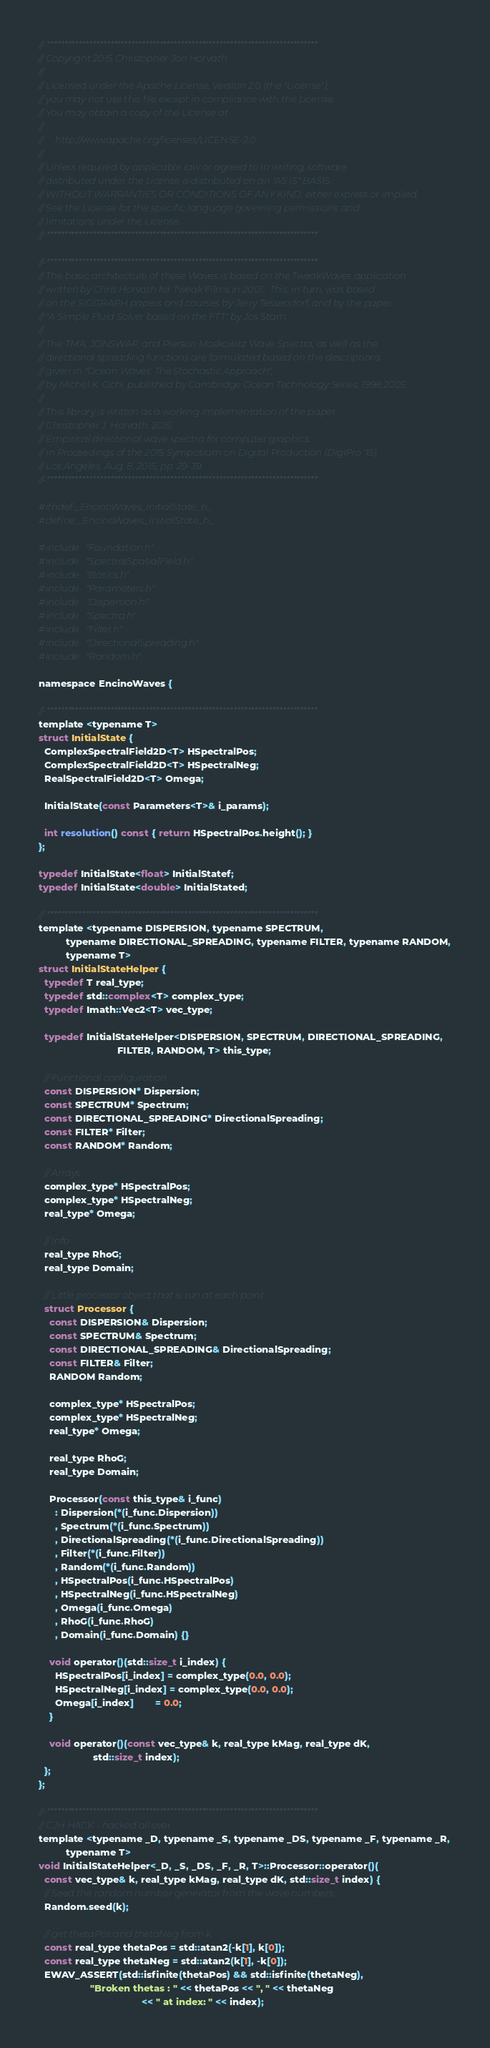<code> <loc_0><loc_0><loc_500><loc_500><_C_>//-*****************************************************************************
// Copyright 2015 Christopher Jon Horvath
//
// Licensed under the Apache License, Version 2.0 (the "License");
// you may not use this file except in compliance with the License.
// You may obtain a copy of the License at
//
//     http://www.apache.org/licenses/LICENSE-2.0
//
// Unless required by applicable law or agreed to in writing, software
// distributed under the License is distributed on an "AS IS" BASIS,
// WITHOUT WARRANTIES OR CONDITIONS OF ANY KIND, either express or implied.
// See the License for the specific language governing permissions and
// limitations under the License.
//-*****************************************************************************

//-*****************************************************************************
// The basic architecture of these Waves is based on the TweakWaves application
// written by Chris Horvath for Tweak Films in 2001.  This, in turn, was based
// on the SIGGRAPH papers and courses by Jerry Tessendorf, and by the paper
// "A Simple Fluid Solver based on the FTT" by Jos Stam.
//
// The TMA, JONSWAP, and Pierson Moskowitz Wave Spectra, as well as the
// directional spreading functions are formulated based on the descriptions
// given in "Ocean Waves: The Stochastic Approach",
// by Michel K. Ochi, published by Cambridge Ocean Technology Series, 1998,2005.
//
// This library is written as a working implementation of the paper:
// Christopher J. Horvath. 2015.
// Empirical directional wave spectra for computer graphics.
// In Proceedings of the 2015 Symposium on Digital Production (DigiPro '15),
// Los Angeles, Aug. 8, 2015, pp. 29-39.
//-*****************************************************************************

#ifndef _EncinoWaves_InitialState_h_
#define _EncinoWaves_InitialState_h_

#include "Foundation.h"
#include "SpectralSpatialField.h"
#include "Basics.h"
#include "Parameters.h"
#include "Dispersion.h"
#include "Spectra.h"
#include "Filter.h"
#include "DirectionalSpreading.h"
#include "Random.h"

namespace EncinoWaves {

//-*****************************************************************************
template <typename T>
struct InitialState {
  ComplexSpectralField2D<T> HSpectralPos;
  ComplexSpectralField2D<T> HSpectralNeg;
  RealSpectralField2D<T> Omega;

  InitialState(const Parameters<T>& i_params);

  int resolution() const { return HSpectralPos.height(); }
};

typedef InitialState<float> InitialStatef;
typedef InitialState<double> InitialStated;

//-*****************************************************************************
template <typename DISPERSION, typename SPECTRUM,
          typename DIRECTIONAL_SPREADING, typename FILTER, typename RANDOM,
          typename T>
struct InitialStateHelper {
  typedef T real_type;
  typedef std::complex<T> complex_type;
  typedef Imath::Vec2<T> vec_type;

  typedef InitialStateHelper<DISPERSION, SPECTRUM, DIRECTIONAL_SPREADING,
                             FILTER, RANDOM, T> this_type;

  // Functional configuration
  const DISPERSION* Dispersion;
  const SPECTRUM* Spectrum;
  const DIRECTIONAL_SPREADING* DirectionalSpreading;
  const FILTER* Filter;
  const RANDOM* Random;

  // Arrays
  complex_type* HSpectralPos;
  complex_type* HSpectralNeg;
  real_type* Omega;

  // Info
  real_type RhoG;
  real_type Domain;

  // Little processor object that is run at each point.
  struct Processor {
    const DISPERSION& Dispersion;
    const SPECTRUM& Spectrum;
    const DIRECTIONAL_SPREADING& DirectionalSpreading;
    const FILTER& Filter;
    RANDOM Random;

    complex_type* HSpectralPos;
    complex_type* HSpectralNeg;
    real_type* Omega;

    real_type RhoG;
    real_type Domain;

    Processor(const this_type& i_func)
      : Dispersion(*(i_func.Dispersion))
      , Spectrum(*(i_func.Spectrum))
      , DirectionalSpreading(*(i_func.DirectionalSpreading))
      , Filter(*(i_func.Filter))
      , Random(*(i_func.Random))
      , HSpectralPos(i_func.HSpectralPos)
      , HSpectralNeg(i_func.HSpectralNeg)
      , Omega(i_func.Omega)
      , RhoG(i_func.RhoG)
      , Domain(i_func.Domain) {}

    void operator()(std::size_t i_index) {
      HSpectralPos[i_index] = complex_type(0.0, 0.0);
      HSpectralNeg[i_index] = complex_type(0.0, 0.0);
      Omega[i_index]        = 0.0;
    }

    void operator()(const vec_type& k, real_type kMag, real_type dK,
                    std::size_t index);
  };
};

//-*****************************************************************************
// CJH HACK - hacked all over
template <typename _D, typename _S, typename _DS, typename _F, typename _R,
          typename T>
void InitialStateHelper<_D, _S, _DS, _F, _R, T>::Processor::operator()(
  const vec_type& k, real_type kMag, real_type dK, std::size_t index) {
  // Seed the random number generator from the wave numbers.
  Random.seed(k);

  // get thetaPos and thetaNeg from k.
  const real_type thetaPos = std::atan2(-k[1], k[0]);
  const real_type thetaNeg = std::atan2(k[1], -k[0]);
  EWAV_ASSERT(std::isfinite(thetaPos) && std::isfinite(thetaNeg),
                   "Broken thetas : " << thetaPos << ", " << thetaNeg
                                      << " at index: " << index);
</code> 